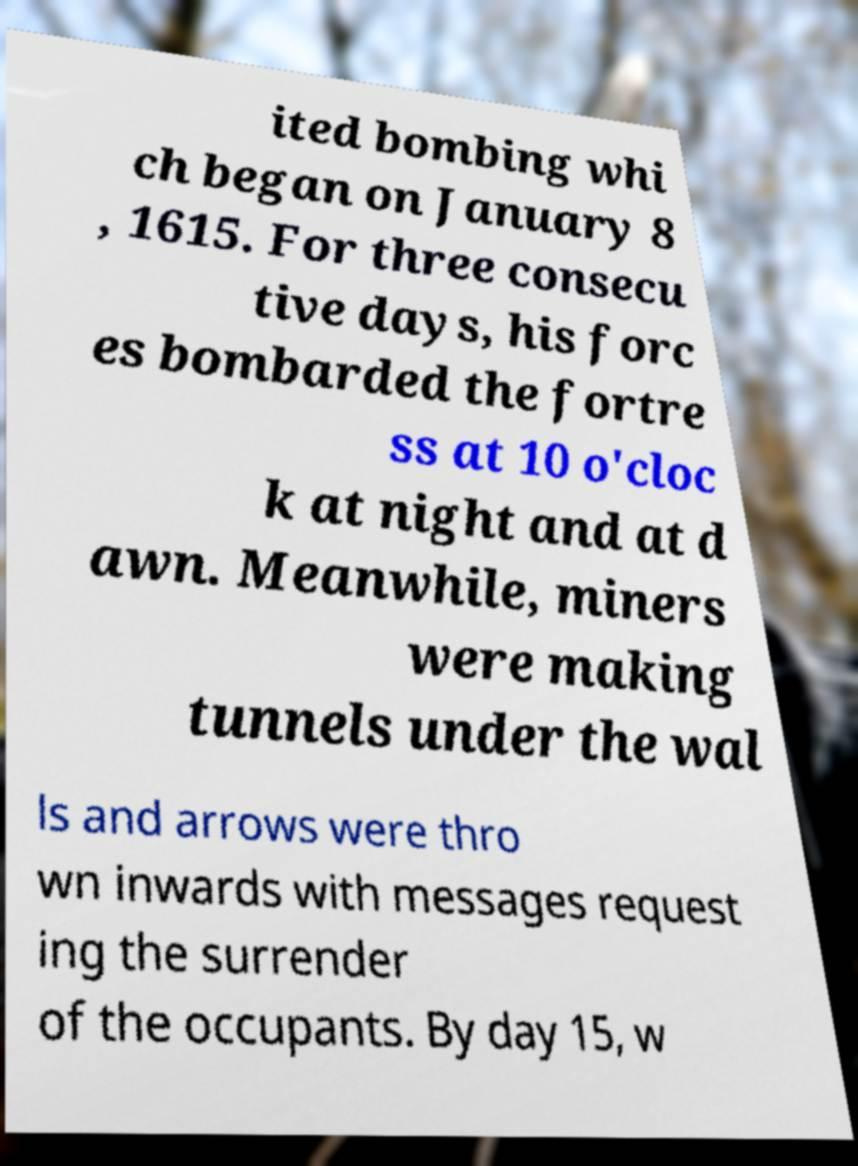Could you assist in decoding the text presented in this image and type it out clearly? ited bombing whi ch began on January 8 , 1615. For three consecu tive days, his forc es bombarded the fortre ss at 10 o'cloc k at night and at d awn. Meanwhile, miners were making tunnels under the wal ls and arrows were thro wn inwards with messages request ing the surrender of the occupants. By day 15, w 